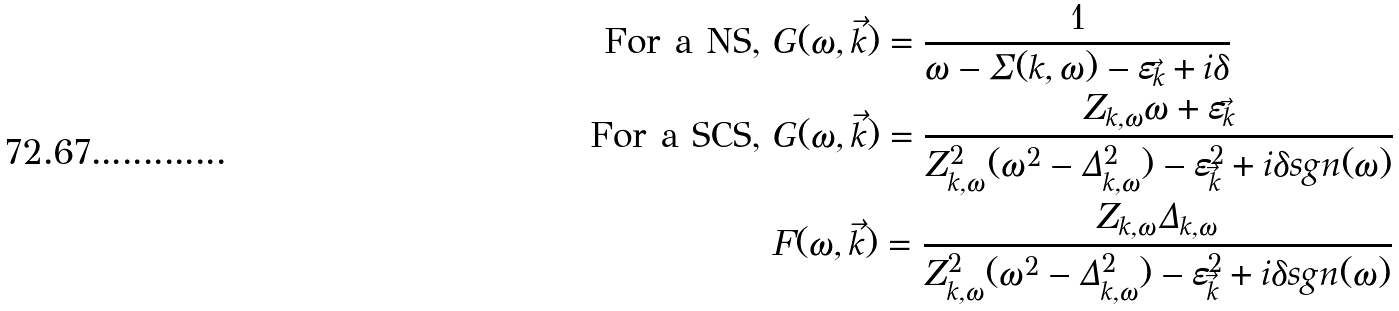Convert formula to latex. <formula><loc_0><loc_0><loc_500><loc_500>\text {For a NS,\  } & G ( \omega , \vec { k } ) = \frac { 1 } { \omega - \Sigma ( k , \omega ) - \varepsilon _ { \vec { k } } + i \delta } \\ \text {For a SCS,\ } & G ( \omega , \vec { k } ) = \frac { Z _ { k , \omega } \omega + \varepsilon _ { \vec { k } } } { Z ^ { 2 } _ { k , \omega } ( \omega ^ { 2 } - \Delta ^ { 2 } _ { k , \omega } ) - \varepsilon _ { \vec { k } } ^ { 2 } + i \delta s g n ( \omega ) } \\ & F ( \omega , \vec { k } ) = \frac { Z _ { k , \omega } \Delta _ { k , \omega } } { Z ^ { 2 } _ { k , \omega } ( \omega ^ { 2 } - \Delta ^ { 2 } _ { k , \omega } ) - \varepsilon _ { \vec { k } } ^ { 2 } + i \delta s g n ( \omega ) }</formula> 